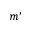Convert formula to latex. <formula><loc_0><loc_0><loc_500><loc_500>m ^ { \prime }</formula> 